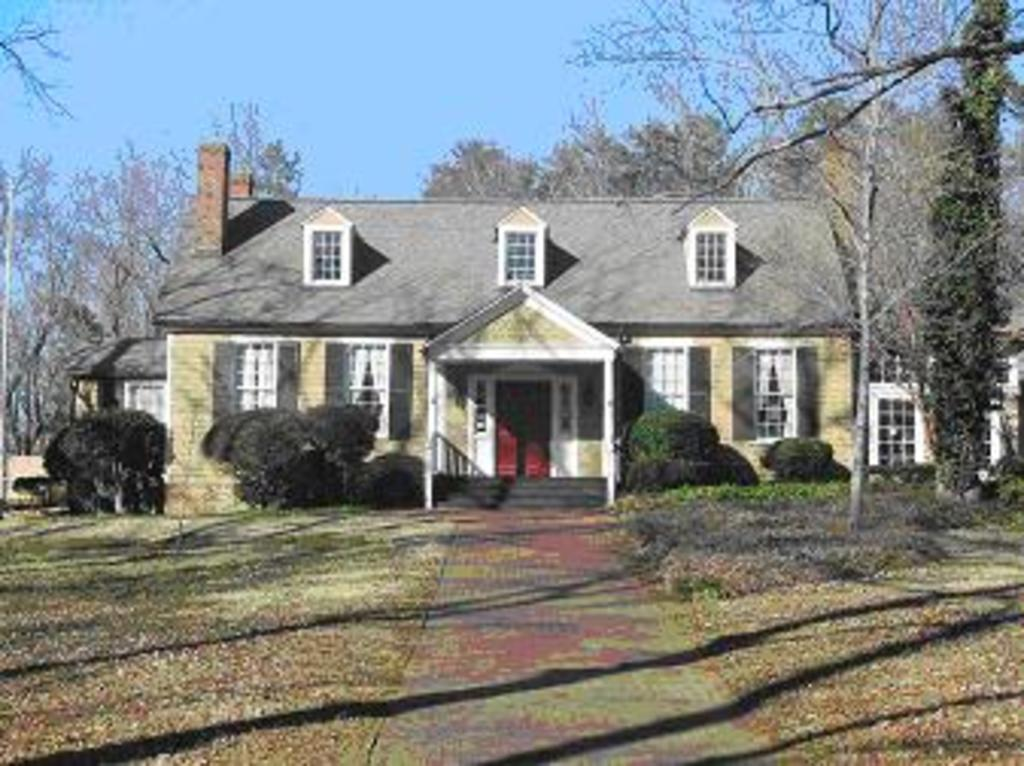What type of structures can be seen in the image? There are buildings in the image. What architectural features are visible on the buildings? There are windows, doors, and stairs visible on the buildings. What type of vegetation is present in the image? There are trees in the image. What is the color of the sky in the image? The sky is blue in the image. Who is the representative of the basket in the image? There is no representative of a basket present in the image. What type of needle can be seen in the image? There is no needle present in the image. 